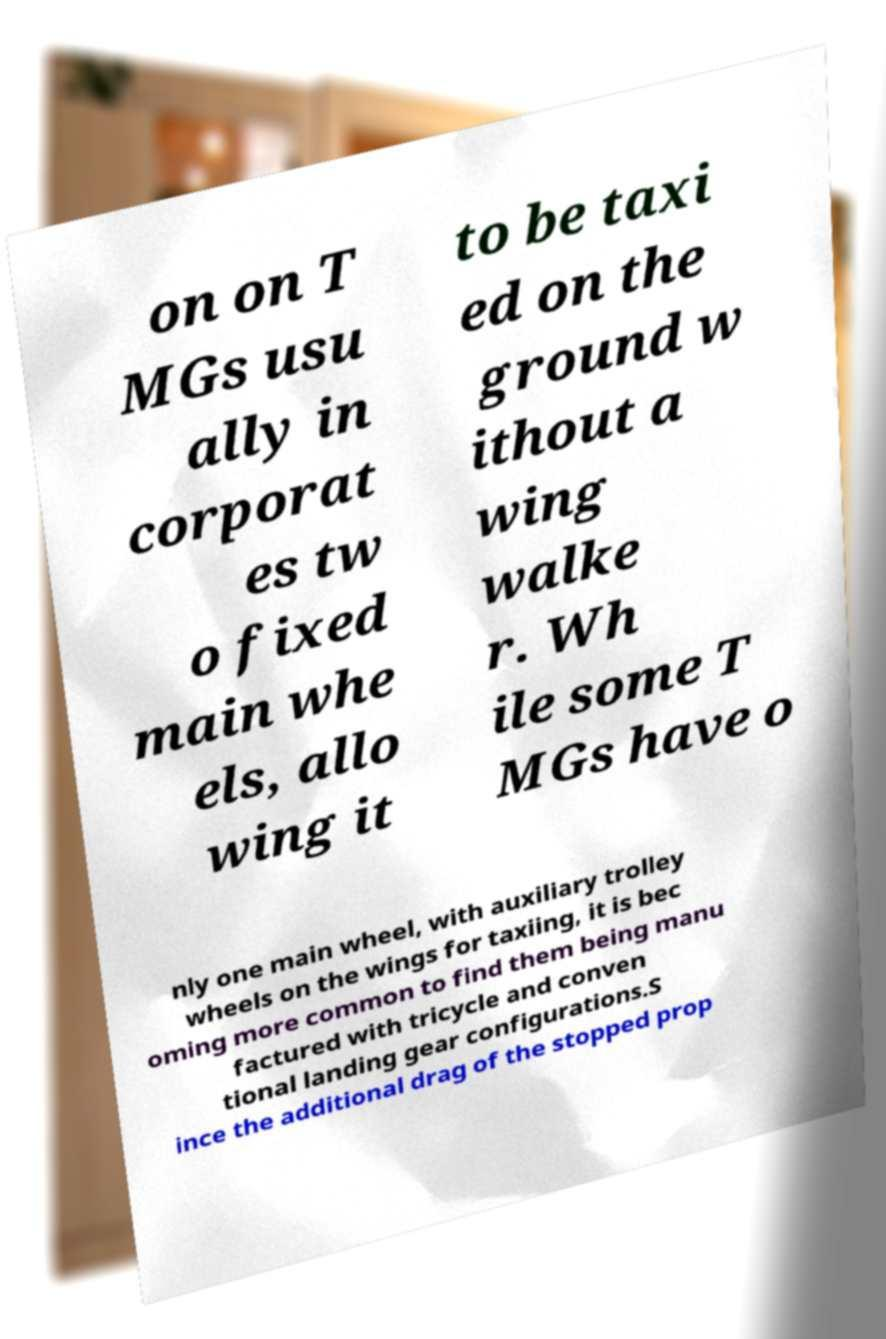Can you accurately transcribe the text from the provided image for me? on on T MGs usu ally in corporat es tw o fixed main whe els, allo wing it to be taxi ed on the ground w ithout a wing walke r. Wh ile some T MGs have o nly one main wheel, with auxiliary trolley wheels on the wings for taxiing, it is bec oming more common to find them being manu factured with tricycle and conven tional landing gear configurations.S ince the additional drag of the stopped prop 